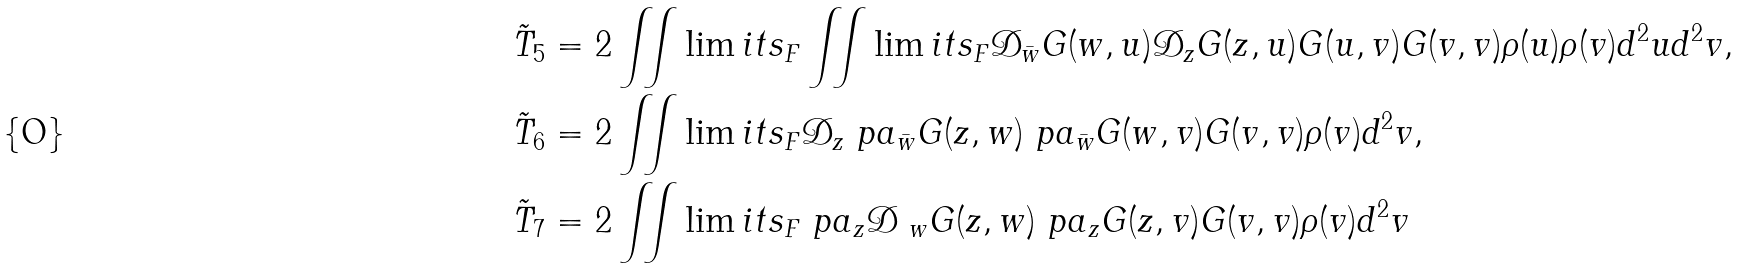Convert formula to latex. <formula><loc_0><loc_0><loc_500><loc_500>\tilde { T } _ { 5 } & = 2 \iint \lim i t s _ { F } \iint \lim i t s _ { F } \mathcal { D } _ { \bar { w } } G ( w , u ) \mathcal { D } _ { z } G ( z , u ) G ( u , v ) G ( v , v ) \rho ( u ) \rho ( v ) d ^ { 2 } u d ^ { 2 } v , \\ \tilde { T } _ { 6 } & = 2 \iint \lim i t s _ { F } \mathcal { D } _ { z } \ p a _ { \bar { w } } G ( z , w ) \ p a _ { \bar { w } } G ( w , v ) G ( v , v ) \rho ( v ) d ^ { 2 } v , \\ \tilde { T } _ { 7 } & = 2 \iint \lim i t s _ { F } \ p a _ { z } \mathcal { D } _ { \ w } G ( z , w ) \ p a _ { z } G ( z , v ) G ( v , v ) \rho ( v ) d ^ { 2 } v</formula> 